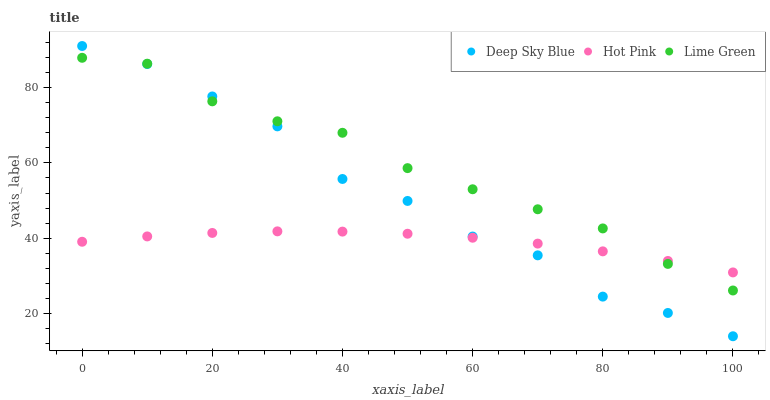Does Hot Pink have the minimum area under the curve?
Answer yes or no. Yes. Does Lime Green have the maximum area under the curve?
Answer yes or no. Yes. Does Deep Sky Blue have the minimum area under the curve?
Answer yes or no. No. Does Deep Sky Blue have the maximum area under the curve?
Answer yes or no. No. Is Hot Pink the smoothest?
Answer yes or no. Yes. Is Deep Sky Blue the roughest?
Answer yes or no. Yes. Is Lime Green the smoothest?
Answer yes or no. No. Is Lime Green the roughest?
Answer yes or no. No. Does Deep Sky Blue have the lowest value?
Answer yes or no. Yes. Does Lime Green have the lowest value?
Answer yes or no. No. Does Deep Sky Blue have the highest value?
Answer yes or no. Yes. Does Lime Green have the highest value?
Answer yes or no. No. Does Lime Green intersect Hot Pink?
Answer yes or no. Yes. Is Lime Green less than Hot Pink?
Answer yes or no. No. Is Lime Green greater than Hot Pink?
Answer yes or no. No. 